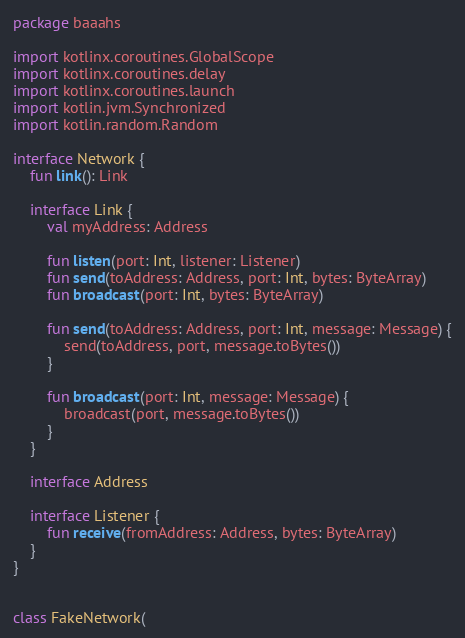<code> <loc_0><loc_0><loc_500><loc_500><_Kotlin_>package baaahs

import kotlinx.coroutines.GlobalScope
import kotlinx.coroutines.delay
import kotlinx.coroutines.launch
import kotlin.jvm.Synchronized
import kotlin.random.Random

interface Network {
    fun link(): Link

    interface Link {
        val myAddress: Address

        fun listen(port: Int, listener: Listener)
        fun send(toAddress: Address, port: Int, bytes: ByteArray)
        fun broadcast(port: Int, bytes: ByteArray)

        fun send(toAddress: Address, port: Int, message: Message) {
            send(toAddress, port, message.toBytes())
        }

        fun broadcast(port: Int, message: Message) {
            broadcast(port, message.toBytes())
        }
    }

    interface Address

    interface Listener {
        fun receive(fromAddress: Address, bytes: ByteArray)
    }
}


class FakeNetwork(</code> 